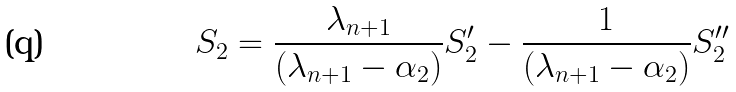Convert formula to latex. <formula><loc_0><loc_0><loc_500><loc_500>S _ { 2 } = \frac { \lambda _ { n + 1 } } { ( \lambda _ { n + 1 } - \alpha _ { 2 } ) } S _ { 2 } ^ { \prime } - \frac { 1 } { ( \lambda _ { n + 1 } - \alpha _ { 2 } ) } S _ { 2 } ^ { \prime \prime }</formula> 